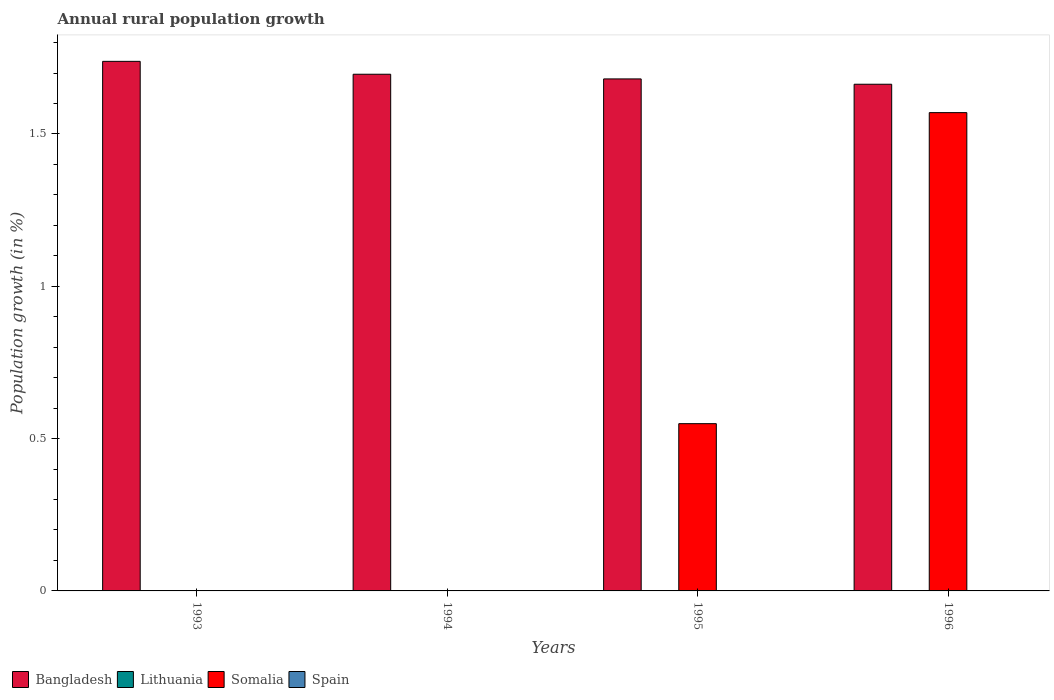How many different coloured bars are there?
Your response must be concise. 2. Are the number of bars per tick equal to the number of legend labels?
Your response must be concise. No. Are the number of bars on each tick of the X-axis equal?
Your answer should be compact. No. How many bars are there on the 1st tick from the left?
Make the answer very short. 1. How many bars are there on the 1st tick from the right?
Keep it short and to the point. 2. What is the label of the 3rd group of bars from the left?
Make the answer very short. 1995. In how many cases, is the number of bars for a given year not equal to the number of legend labels?
Your answer should be compact. 4. What is the percentage of rural population growth in Spain in 1994?
Give a very brief answer. 0. Across all years, what is the maximum percentage of rural population growth in Somalia?
Ensure brevity in your answer.  1.57. Across all years, what is the minimum percentage of rural population growth in Bangladesh?
Ensure brevity in your answer.  1.66. In which year was the percentage of rural population growth in Bangladesh maximum?
Provide a succinct answer. 1993. What is the total percentage of rural population growth in Lithuania in the graph?
Make the answer very short. 0. What is the difference between the percentage of rural population growth in Bangladesh in 1995 and that in 1996?
Provide a short and direct response. 0.02. What is the difference between the percentage of rural population growth in Spain in 1993 and the percentage of rural population growth in Somalia in 1995?
Offer a very short reply. -0.55. What is the average percentage of rural population growth in Spain per year?
Provide a succinct answer. 0. In how many years, is the percentage of rural population growth in Somalia greater than 1 %?
Make the answer very short. 1. What is the ratio of the percentage of rural population growth in Bangladesh in 1993 to that in 1996?
Provide a succinct answer. 1.05. Is the percentage of rural population growth in Bangladesh in 1995 less than that in 1996?
Offer a terse response. No. What is the difference between the highest and the second highest percentage of rural population growth in Bangladesh?
Give a very brief answer. 0.04. What is the difference between the highest and the lowest percentage of rural population growth in Somalia?
Ensure brevity in your answer.  1.57. Is it the case that in every year, the sum of the percentage of rural population growth in Lithuania and percentage of rural population growth in Somalia is greater than the sum of percentage of rural population growth in Spain and percentage of rural population growth in Bangladesh?
Your response must be concise. No. Are all the bars in the graph horizontal?
Keep it short and to the point. No. How many years are there in the graph?
Offer a terse response. 4. What is the difference between two consecutive major ticks on the Y-axis?
Give a very brief answer. 0.5. Does the graph contain any zero values?
Keep it short and to the point. Yes. How are the legend labels stacked?
Offer a terse response. Horizontal. What is the title of the graph?
Your answer should be very brief. Annual rural population growth. Does "Congo (Republic)" appear as one of the legend labels in the graph?
Make the answer very short. No. What is the label or title of the Y-axis?
Ensure brevity in your answer.  Population growth (in %). What is the Population growth (in %) in Bangladesh in 1993?
Keep it short and to the point. 1.74. What is the Population growth (in %) in Lithuania in 1993?
Provide a short and direct response. 0. What is the Population growth (in %) of Bangladesh in 1994?
Give a very brief answer. 1.7. What is the Population growth (in %) of Lithuania in 1994?
Offer a terse response. 0. What is the Population growth (in %) of Spain in 1994?
Make the answer very short. 0. What is the Population growth (in %) of Bangladesh in 1995?
Keep it short and to the point. 1.68. What is the Population growth (in %) of Somalia in 1995?
Your answer should be compact. 0.55. What is the Population growth (in %) in Spain in 1995?
Offer a very short reply. 0. What is the Population growth (in %) in Bangladesh in 1996?
Your answer should be very brief. 1.66. What is the Population growth (in %) in Lithuania in 1996?
Provide a succinct answer. 0. What is the Population growth (in %) in Somalia in 1996?
Keep it short and to the point. 1.57. Across all years, what is the maximum Population growth (in %) of Bangladesh?
Your answer should be very brief. 1.74. Across all years, what is the maximum Population growth (in %) of Somalia?
Provide a succinct answer. 1.57. Across all years, what is the minimum Population growth (in %) of Bangladesh?
Your response must be concise. 1.66. What is the total Population growth (in %) in Bangladesh in the graph?
Your response must be concise. 6.78. What is the total Population growth (in %) of Lithuania in the graph?
Provide a short and direct response. 0. What is the total Population growth (in %) of Somalia in the graph?
Offer a terse response. 2.12. What is the difference between the Population growth (in %) in Bangladesh in 1993 and that in 1994?
Make the answer very short. 0.04. What is the difference between the Population growth (in %) of Bangladesh in 1993 and that in 1995?
Your response must be concise. 0.06. What is the difference between the Population growth (in %) in Bangladesh in 1993 and that in 1996?
Keep it short and to the point. 0.08. What is the difference between the Population growth (in %) in Bangladesh in 1994 and that in 1995?
Offer a very short reply. 0.02. What is the difference between the Population growth (in %) of Bangladesh in 1994 and that in 1996?
Your answer should be very brief. 0.03. What is the difference between the Population growth (in %) of Bangladesh in 1995 and that in 1996?
Your answer should be very brief. 0.02. What is the difference between the Population growth (in %) of Somalia in 1995 and that in 1996?
Your answer should be compact. -1.02. What is the difference between the Population growth (in %) of Bangladesh in 1993 and the Population growth (in %) of Somalia in 1995?
Ensure brevity in your answer.  1.19. What is the difference between the Population growth (in %) of Bangladesh in 1993 and the Population growth (in %) of Somalia in 1996?
Give a very brief answer. 0.17. What is the difference between the Population growth (in %) in Bangladesh in 1994 and the Population growth (in %) in Somalia in 1995?
Provide a short and direct response. 1.15. What is the difference between the Population growth (in %) of Bangladesh in 1994 and the Population growth (in %) of Somalia in 1996?
Ensure brevity in your answer.  0.13. What is the difference between the Population growth (in %) of Bangladesh in 1995 and the Population growth (in %) of Somalia in 1996?
Provide a succinct answer. 0.11. What is the average Population growth (in %) in Bangladesh per year?
Your answer should be very brief. 1.69. What is the average Population growth (in %) in Somalia per year?
Offer a very short reply. 0.53. In the year 1995, what is the difference between the Population growth (in %) in Bangladesh and Population growth (in %) in Somalia?
Your response must be concise. 1.13. In the year 1996, what is the difference between the Population growth (in %) in Bangladesh and Population growth (in %) in Somalia?
Your answer should be very brief. 0.09. What is the ratio of the Population growth (in %) in Bangladesh in 1993 to that in 1994?
Provide a succinct answer. 1.02. What is the ratio of the Population growth (in %) of Bangladesh in 1993 to that in 1995?
Your answer should be very brief. 1.03. What is the ratio of the Population growth (in %) of Bangladesh in 1993 to that in 1996?
Provide a succinct answer. 1.05. What is the ratio of the Population growth (in %) of Bangladesh in 1994 to that in 1995?
Offer a terse response. 1.01. What is the ratio of the Population growth (in %) of Bangladesh in 1994 to that in 1996?
Make the answer very short. 1.02. What is the ratio of the Population growth (in %) in Bangladesh in 1995 to that in 1996?
Keep it short and to the point. 1.01. What is the ratio of the Population growth (in %) of Somalia in 1995 to that in 1996?
Ensure brevity in your answer.  0.35. What is the difference between the highest and the second highest Population growth (in %) in Bangladesh?
Your response must be concise. 0.04. What is the difference between the highest and the lowest Population growth (in %) of Bangladesh?
Your response must be concise. 0.08. What is the difference between the highest and the lowest Population growth (in %) in Somalia?
Offer a terse response. 1.57. 